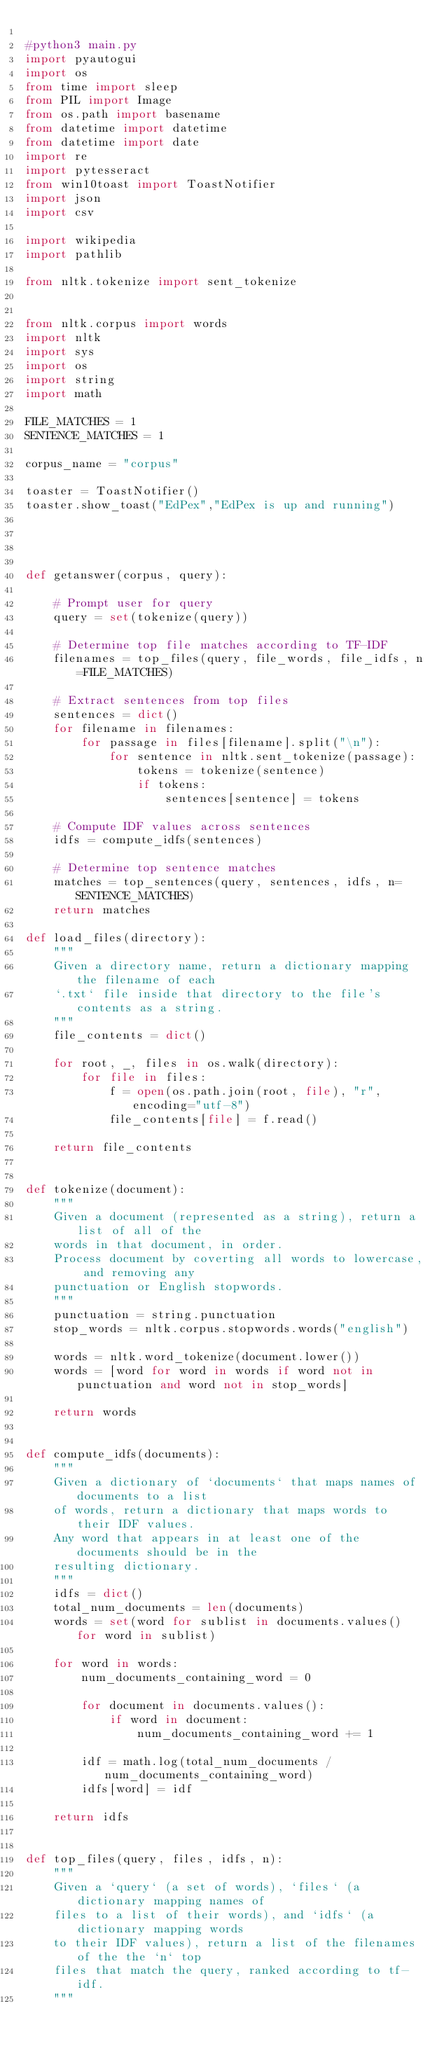Convert code to text. <code><loc_0><loc_0><loc_500><loc_500><_Python_>
#python3 main.py
import pyautogui
import os
from time import sleep
from PIL import Image
from os.path import basename
from datetime import datetime
from datetime import date
import re
import pytesseract   
from win10toast import ToastNotifier
import json
import csv

import wikipedia
import pathlib

from nltk.tokenize import sent_tokenize


from nltk.corpus import words
import nltk
import sys
import os
import string
import math

FILE_MATCHES = 1
SENTENCE_MATCHES = 1

corpus_name = "corpus"

toaster = ToastNotifier()
toaster.show_toast("EdPex","EdPex is up and running")   




def getanswer(corpus, query):

    # Prompt user for query
    query = set(tokenize(query))

    # Determine top file matches according to TF-IDF
    filenames = top_files(query, file_words, file_idfs, n=FILE_MATCHES)

    # Extract sentences from top files
    sentences = dict()
    for filename in filenames:
        for passage in files[filename].split("\n"):
            for sentence in nltk.sent_tokenize(passage):
                tokens = tokenize(sentence)
                if tokens:
                    sentences[sentence] = tokens

    # Compute IDF values across sentences
    idfs = compute_idfs(sentences)

    # Determine top sentence matches
    matches = top_sentences(query, sentences, idfs, n=SENTENCE_MATCHES)
    return matches

def load_files(directory):
    """
    Given a directory name, return a dictionary mapping the filename of each
    `.txt` file inside that directory to the file's contents as a string.
    """
    file_contents = dict()

    for root, _, files in os.walk(directory):
        for file in files:
            f = open(os.path.join(root, file), "r", encoding="utf-8")
            file_contents[file] = f.read()

    return file_contents


def tokenize(document):
    """
    Given a document (represented as a string), return a list of all of the
    words in that document, in order.
    Process document by coverting all words to lowercase, and removing any
    punctuation or English stopwords.
    """
    punctuation = string.punctuation
    stop_words = nltk.corpus.stopwords.words("english")

    words = nltk.word_tokenize(document.lower())
    words = [word for word in words if word not in punctuation and word not in stop_words]

    return words


def compute_idfs(documents):
    """
    Given a dictionary of `documents` that maps names of documents to a list
    of words, return a dictionary that maps words to their IDF values.
    Any word that appears in at least one of the documents should be in the
    resulting dictionary.
    """
    idfs = dict()
    total_num_documents = len(documents)
    words = set(word for sublist in documents.values() for word in sublist)
    
    for word in words:
        num_documents_containing_word = 0
        
        for document in documents.values():
            if word in document:
                num_documents_containing_word += 1
        
        idf = math.log(total_num_documents / num_documents_containing_word)
        idfs[word] = idf

    return idfs


def top_files(query, files, idfs, n):
    """
    Given a `query` (a set of words), `files` (a dictionary mapping names of
    files to a list of their words), and `idfs` (a dictionary mapping words
    to their IDF values), return a list of the filenames of the the `n` top
    files that match the query, ranked according to tf-idf.
    """</code> 